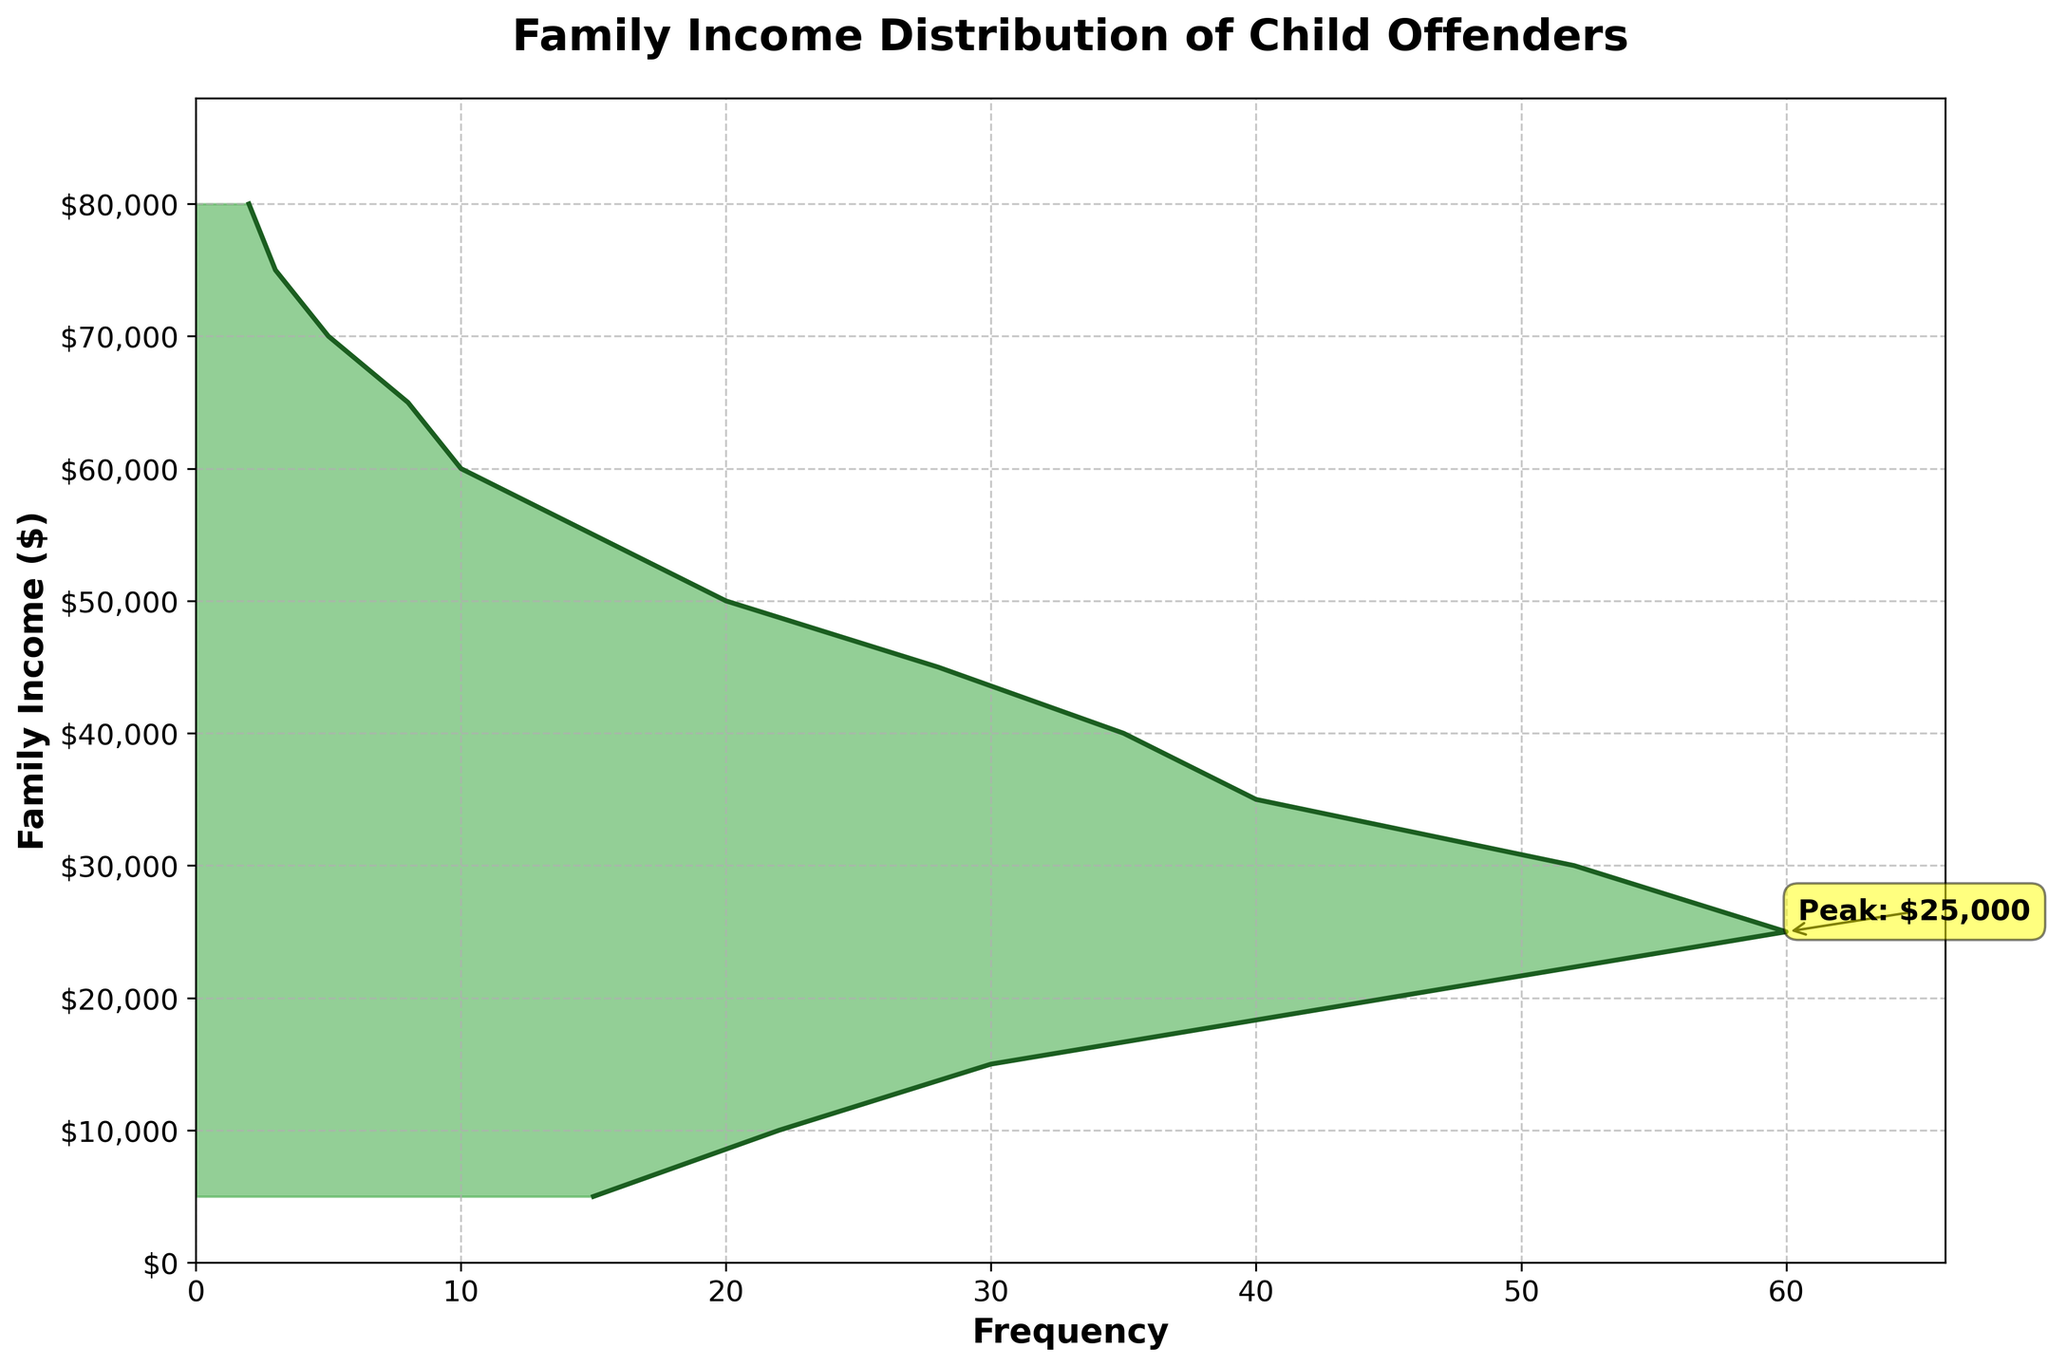What's the title of the chart? The title is displayed at the top center of the plot, which is a detailed description of what the chart represents.
Answer: Family Income Distribution of Child Offenders What income range has the highest frequency? The peak is highlighted by an annotation on the chart, where the frequency is the highest. The annotation shows that the specific income value with the peak frequency is $25,000.
Answer: $25,000 Which family income level has the smallest frequency exactly? By observing the least filled profile and the smallest plotted frequency value, the lowest is at $80,000 with a frequency of 2.
Answer: $80,000 What's the frequency for a family income of $30,000? Locate where the curve intersects with the $30,000 mark on the vertical axis and check the corresponding frequency on the horizontal axis.
Answer: 52 Is the frequency for $60,000 greater than or less than the frequency for $10,000? Observe where the curve intersects both the $60,000 and $10,000 marks on the vertical axis and compare their respective horizontal extensions.
Answer: Less than Is there a drop in frequency after the income level peaks, and if so, how steep is it? After the peak at $25,000, observe the downward slope of the density plot. Compare the height of the curve at the point immediately after the peak to determine the steepness.
Answer: Yes, it gradually decreases from 60 downwards Which income range has a frequency close to 40? Identify the curves hitting around 40 on the horizontal axis and trace where they intersect with the vertical axis. The line crosses 40 at around $35,000 and close to it at $20,000.
Answer: $35,000 How many income brackets have a frequency greater than 50? Count the income range segments along the vertical axis where the curve surpasses the 50 mark. There are segments touching or above 50 at roughly $25,000, $30,000.
Answer: 2 